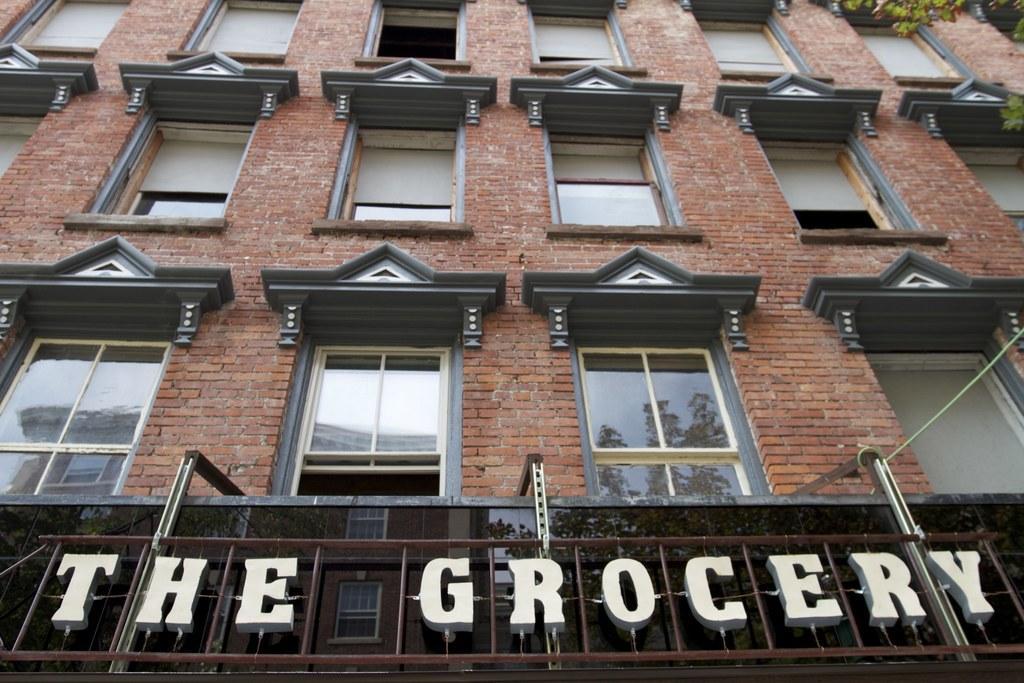Please provide a concise description of this image. In this picture we can see a building with glass windows and a name board. In the top right corner of the image, there is a tree. On the glass windows, we can see the reflections of trees, a building and the sky. 